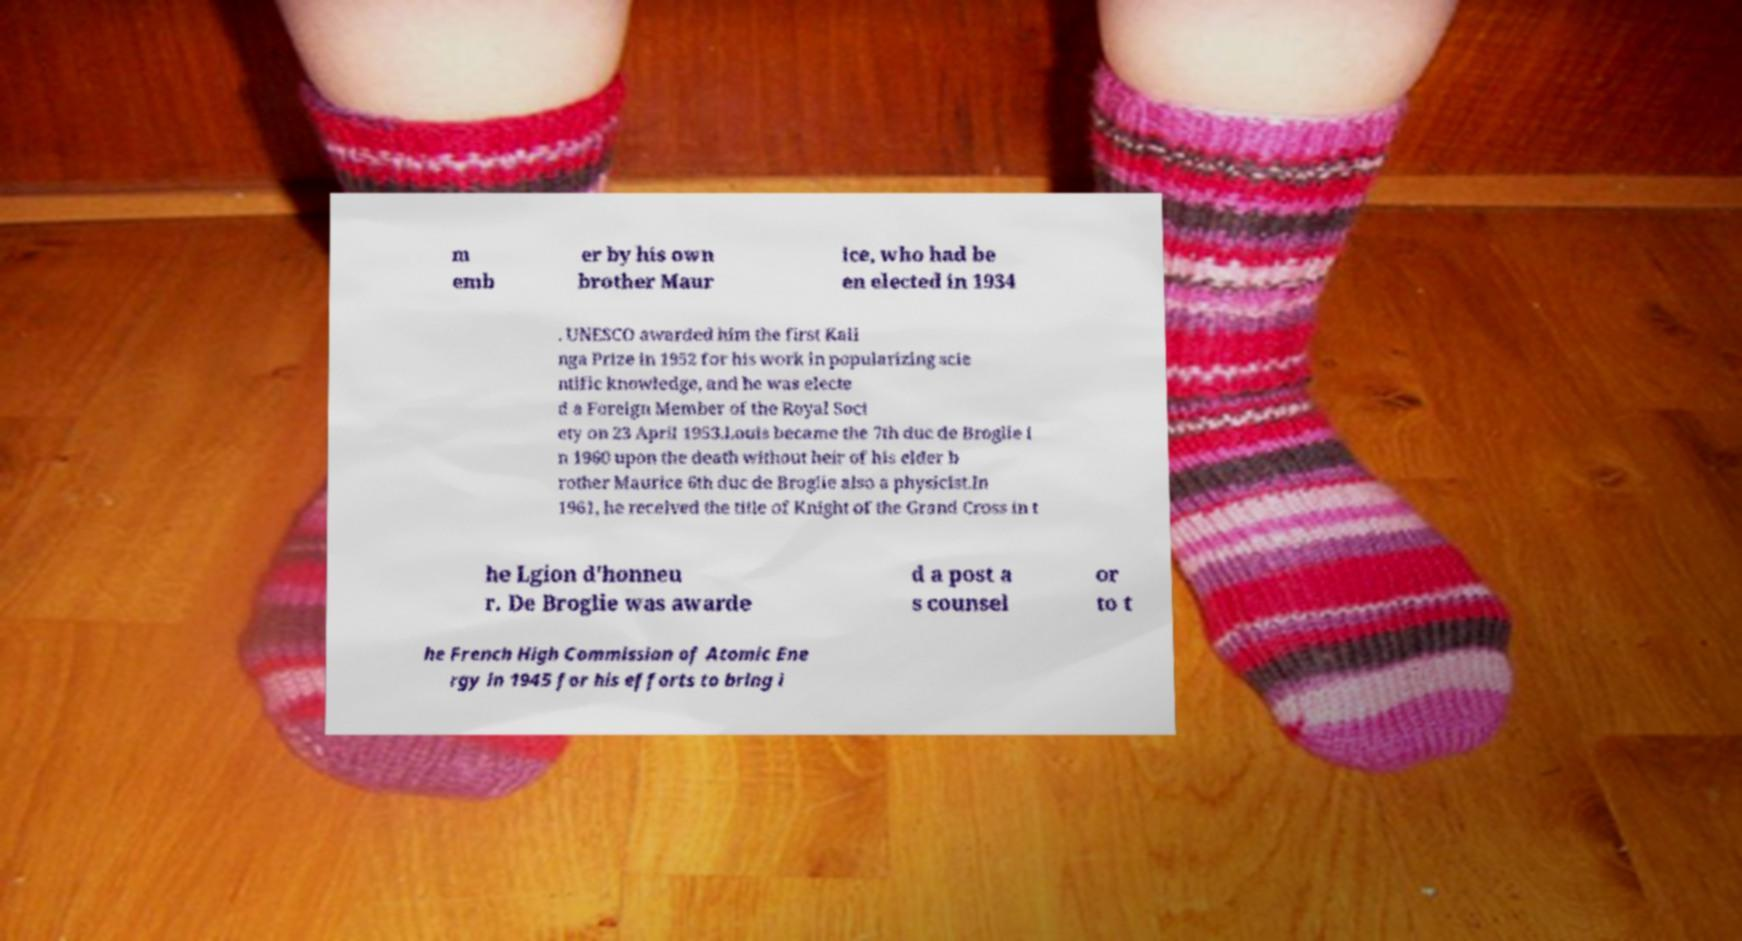Could you assist in decoding the text presented in this image and type it out clearly? m emb er by his own brother Maur ice, who had be en elected in 1934 . UNESCO awarded him the first Kali nga Prize in 1952 for his work in popularizing scie ntific knowledge, and he was electe d a Foreign Member of the Royal Soci ety on 23 April 1953.Louis became the 7th duc de Broglie i n 1960 upon the death without heir of his elder b rother Maurice 6th duc de Broglie also a physicist.In 1961, he received the title of Knight of the Grand Cross in t he Lgion d'honneu r. De Broglie was awarde d a post a s counsel or to t he French High Commission of Atomic Ene rgy in 1945 for his efforts to bring i 